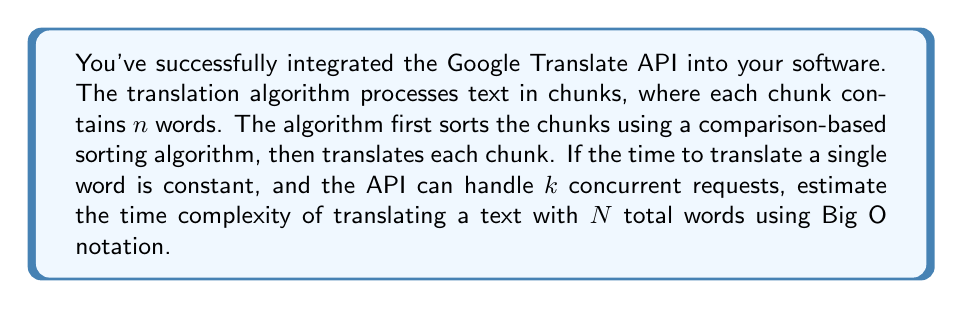Can you answer this question? Let's break this down step-by-step:

1) First, we need to determine the number of chunks:
   Number of chunks = $\frac{N}{n}$

2) Sorting the chunks:
   - Using a comparison-based sorting algorithm (e.g., quicksort), the time complexity for sorting $\frac{N}{n}$ chunks is:
     $$O(\frac{N}{n} \log(\frac{N}{n}))$$

3) Translating the chunks:
   - Each chunk has $n$ words, and we have $\frac{N}{n}$ chunks.
   - The API can handle $k$ concurrent requests.
   - Time to translate all chunks: $O(\frac{N}{kn})$

4) Combining the sorting and translation steps:
   $$O(\frac{N}{n} \log(\frac{N}{n}) + \frac{N}{kn})$$

5) Simplify using the properties of logarithms:
   $$O(\frac{N}{n} (\log N - \log n) + \frac{N}{kn})$$

6) As $N$ grows large, the $\log N$ term will dominate:
   $$O(\frac{N}{n} \log N + \frac{N}{kn})$$

7) Factor out $\frac{N}{n}$:
   $$O(\frac{N}{n} (\log N + \frac{1}{k}))$$

Since $n$ and $k$ are constants, the final time complexity is:
$$O(N \log N)$$
Answer: $O(N \log N)$ 